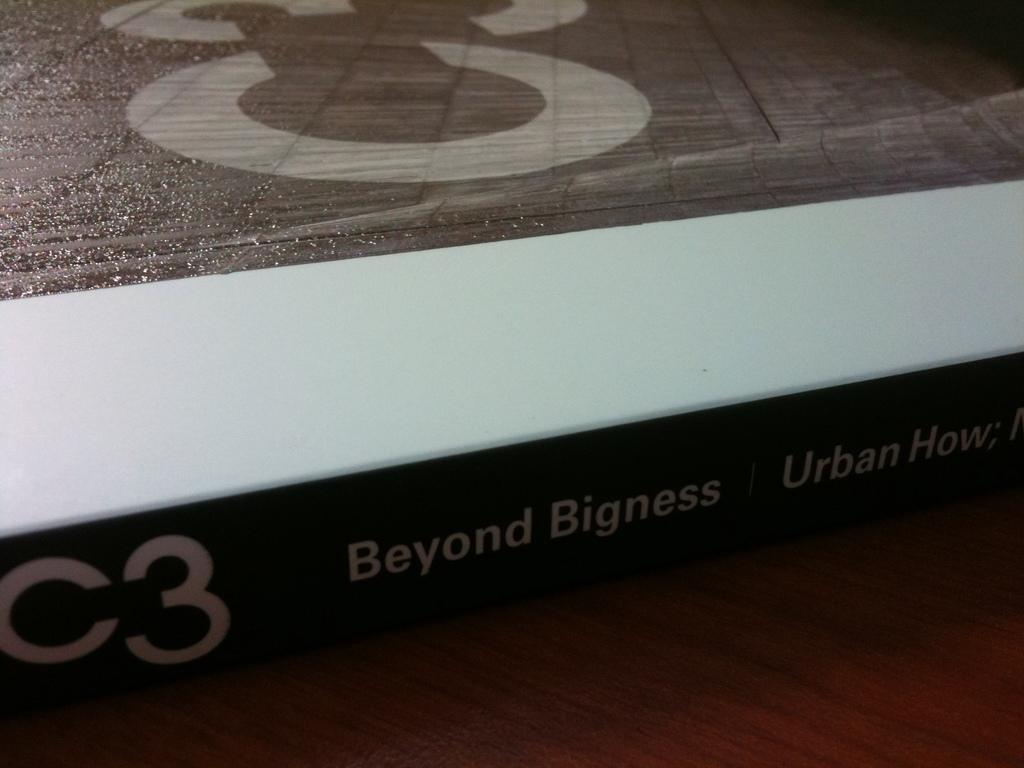<image>
Render a clear and concise summary of the photo. A closeup of C3 Beyond Bigness Urban How edge. 